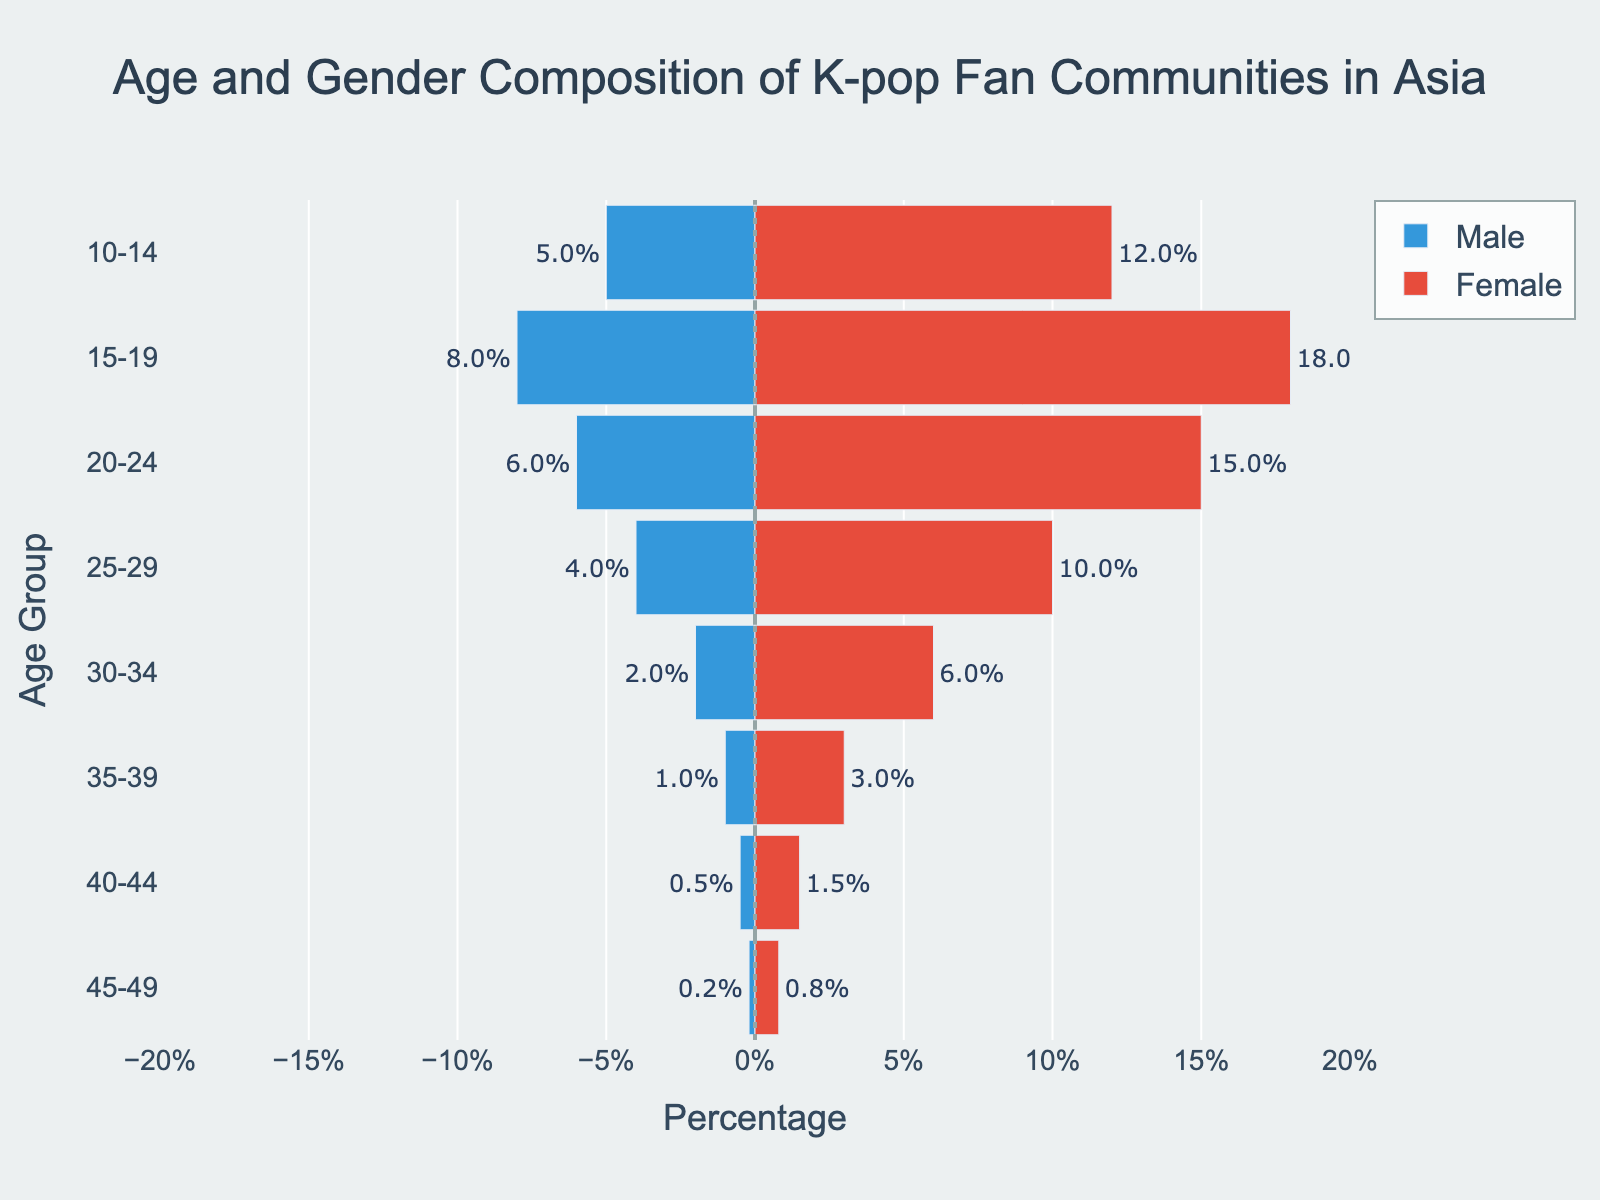what is the title of the figure? The title is displayed prominently at the top of the figure in larger text. It reads "Age and Gender Composition of K-pop Fan Communities in Asia".
Answer: Age and Gender Composition of K-pop Fan Communities in Asia What is the age group with the highest percentage of female fans? The figure consists of horizontal bars where each bar represents an age group. The bar with the longest extension to the right represents the highest percentage of female fans. The age group "15-19" has the longest female bar extending up to 18%.
Answer: 15-19 Which age group has the smallest percentage of male fans? By inspecting the male bars (negative x-axis), we can see that the "45-49" age group has the shortest bar for male fans, with a value of 0.2%.
Answer: 45-49 How many age groups have more female fans than male fans? The female bars are represented by positive values on the x-axis, while the male bars are negative. By checking each age group, we find that all age groups have longer female bars compared to male bars. Therefore, all 8 age groups have more female fans than male fans.
Answer: 8 Which gender has more fans in the "20-24" age group, and by how much? For the "20-24" age group, the female bar extends to 15%, while the male bar extends to -6%. The difference between these values is 15% - 6% = 9%. Females have 9% more fans in this age group.
Answer: Female, 9% What is the total percentage of fans in the "25-29" age group? The total is the sum of the male and female percentages in this age group. The male percentage is 4% and the female percentage is 10%, which totals 4% + 10% = 14%.
Answer: 14% Do any age groups have an equal number of male and female fans? By examining the length of each bar, we observe that no age group has equal lengths for male and female fans. All age groups show a clear difference.
Answer: No Which age group shows the largest difference in percentages between male and female fans? We calculate the difference for each age group. The largest difference is found in the "15-19" age group with female fans at 18% and male fans at 8%, giving a difference of 18% - 8% = 10%.
Answer: 15-19, 10% How does the fan composition in the "30-34" age group compare to the "35-39" age group? In the "30-34" age group, males account for 2% and females for 6%. In the "35-39" age group, males account for 1% and females for 3%. Both gender percentages are higher in the "30-34" age group than in the "35-39" age group.
Answer: 30-34 has more fans than 35-39 for both genders Which color represents female fans in the figure? By examining the bars labeled as 'Female', we observe that they are colored red. The legend also confirms that female bars are represented by the red color.
Answer: Red 